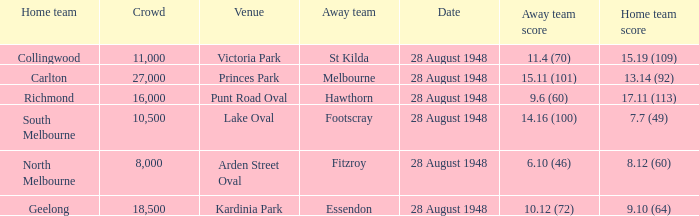What is the St Kilda Away team score? 11.4 (70). 